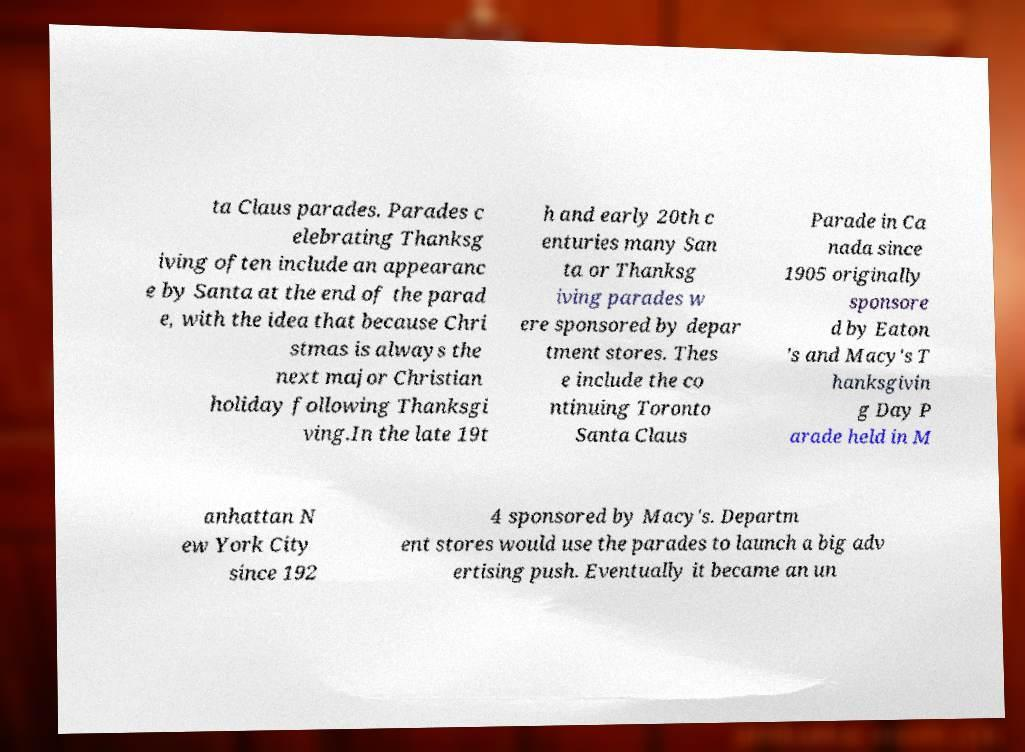Please read and relay the text visible in this image. What does it say? ta Claus parades. Parades c elebrating Thanksg iving often include an appearanc e by Santa at the end of the parad e, with the idea that because Chri stmas is always the next major Christian holiday following Thanksgi ving.In the late 19t h and early 20th c enturies many San ta or Thanksg iving parades w ere sponsored by depar tment stores. Thes e include the co ntinuing Toronto Santa Claus Parade in Ca nada since 1905 originally sponsore d by Eaton 's and Macy's T hanksgivin g Day P arade held in M anhattan N ew York City since 192 4 sponsored by Macy's. Departm ent stores would use the parades to launch a big adv ertising push. Eventually it became an un 